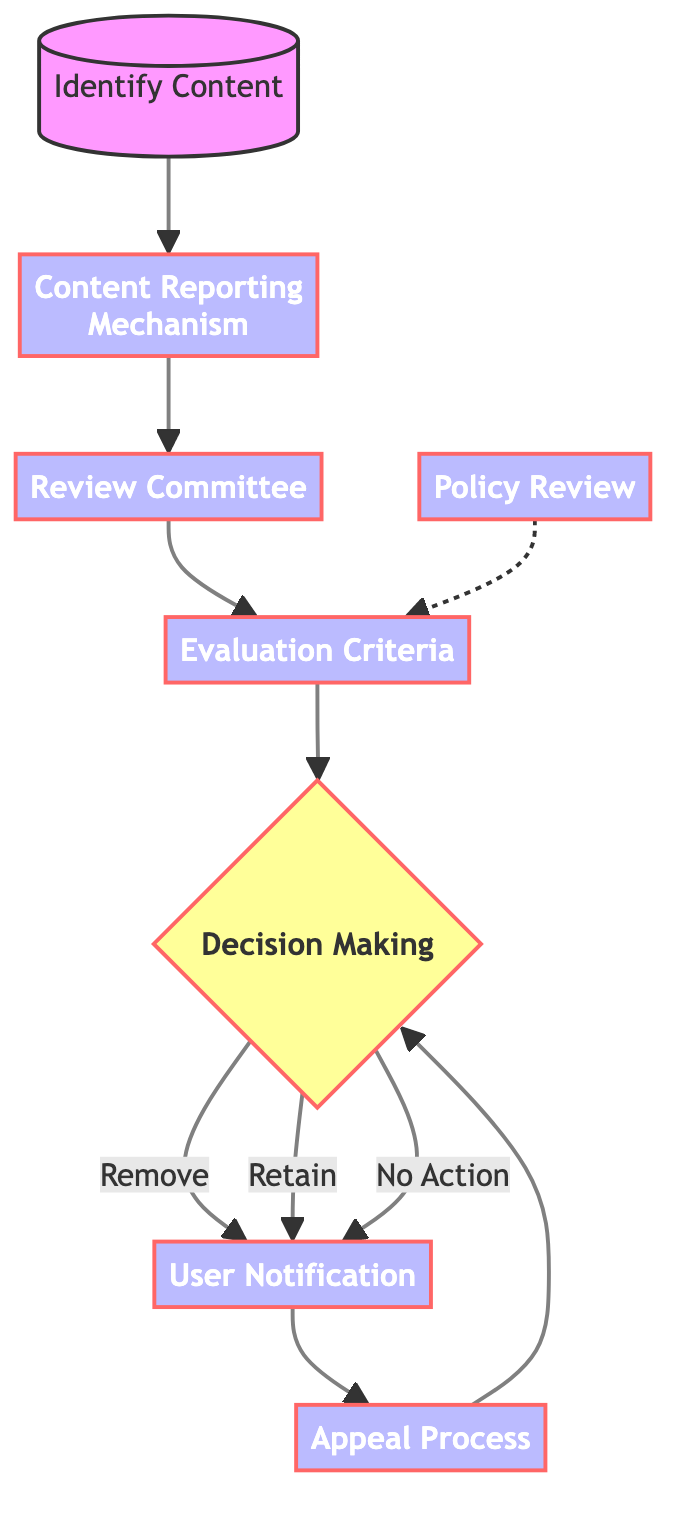What is the first step in the decision-making process? The first step in the flow chart is to "Identify Content," which involves determining the type of content in question, such as hate speech, misinformation, or harassment.
Answer: Identify Content How many main steps are there in the decision-making process? The flow chart consists of eight main steps, including Identify Content, Content Reporting Mechanism, Review Committee, Evaluation Criteria, Decision Making, User Notification, Appeal Process, and Policy Review.
Answer: Eight What is the last step of the flow chart? The last step in the decision-making process depicted in the flow chart is "Policy Review," which indicates the need to assess and update content moderation policies.
Answer: Policy Review What happens after the decision-making step if content is removed? If the content is removed, the next step is "User Notification," where the user is informed about the decision and provided with reasoning.
Answer: User Notification Which step allows users to contest moderation decisions? The step that allows users to contest moderation decisions is called "Appeal Process," which provides a transparent mechanism for appeals.
Answer: Appeal Process What does the evaluation criteria establish? The evaluation criteria establish clear guidelines, including community standards and legal definitions, for assessing the reported content.
Answer: Clear guidelines What is the relationship between the "Policy Review" and "Evaluation Criteria"? The relationship is that the "Policy Review" step is indicated to influence the "Evaluation Criteria," showing a feedback loop where policies are regularly assessed and can lead to updates in evaluation criteria.
Answer: Feedback loop What actions can follow the decision-making node? Following the decision-making node, there are three possible actions: remove the content, retain the content, or take no action.
Answer: Remove, Retain, No Action How is user notification related to the appeal process in the flowchart? In the flow chart, the "User Notification" occurs after the decision-making step, and from there, the user can engage with the "Appeal Process" if they contest the decision made about their content.
Answer: Sequential relationship 